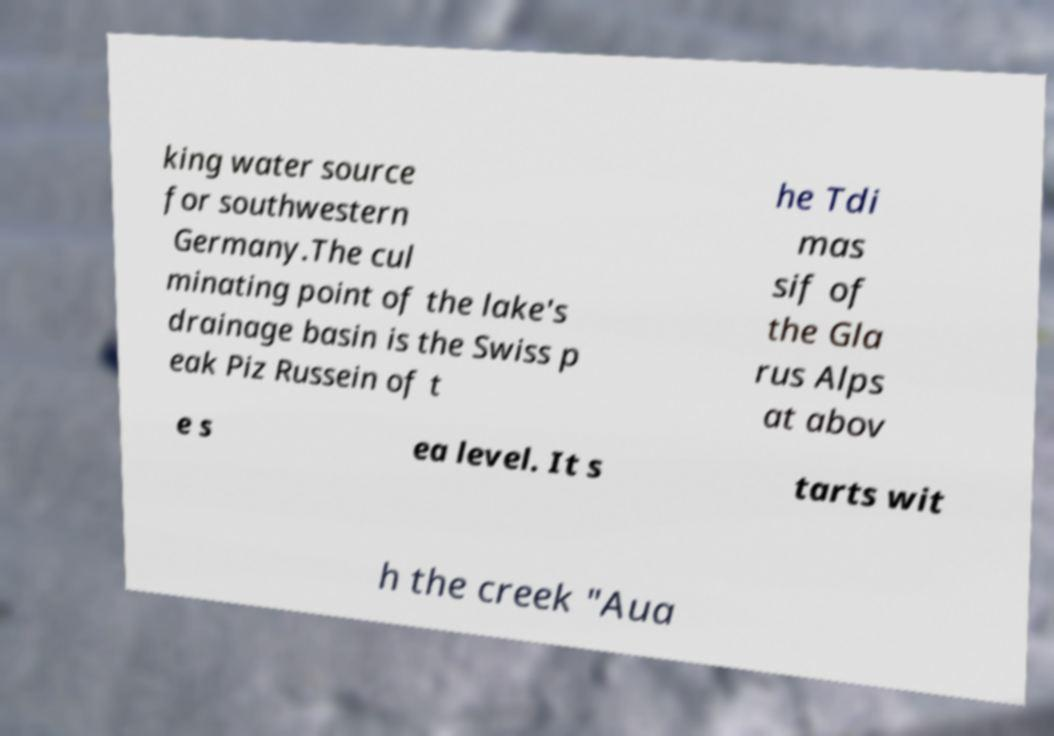There's text embedded in this image that I need extracted. Can you transcribe it verbatim? king water source for southwestern Germany.The cul minating point of the lake's drainage basin is the Swiss p eak Piz Russein of t he Tdi mas sif of the Gla rus Alps at abov e s ea level. It s tarts wit h the creek "Aua 